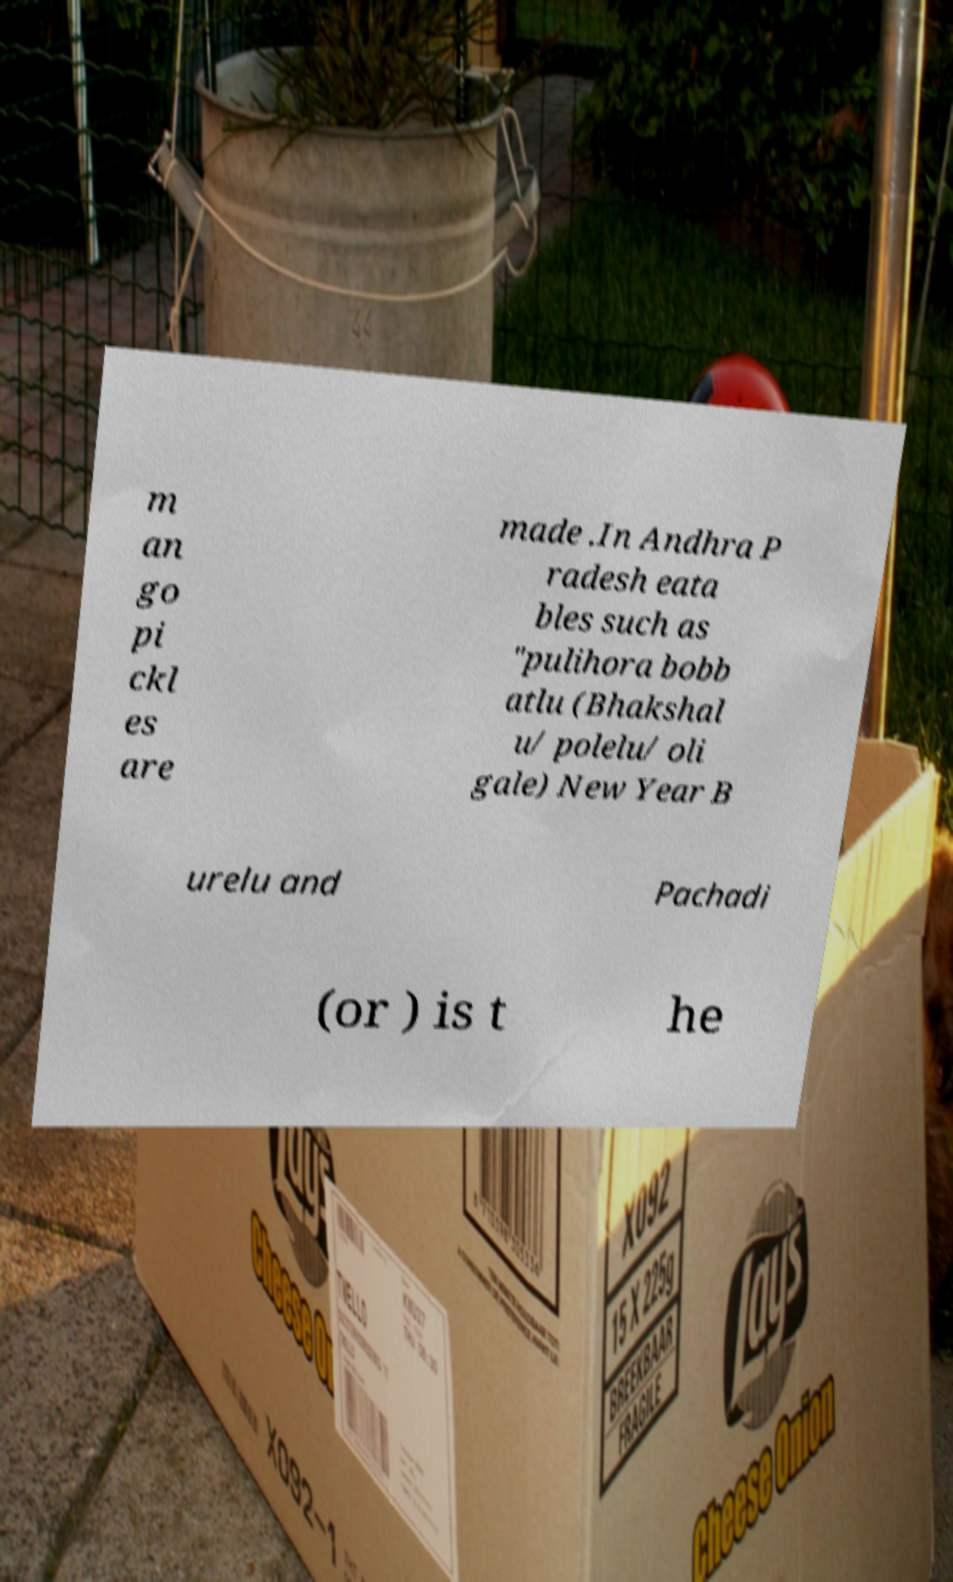I need the written content from this picture converted into text. Can you do that? m an go pi ckl es are made .In Andhra P radesh eata bles such as "pulihora bobb atlu (Bhakshal u/ polelu/ oli gale) New Year B urelu and Pachadi (or ) is t he 